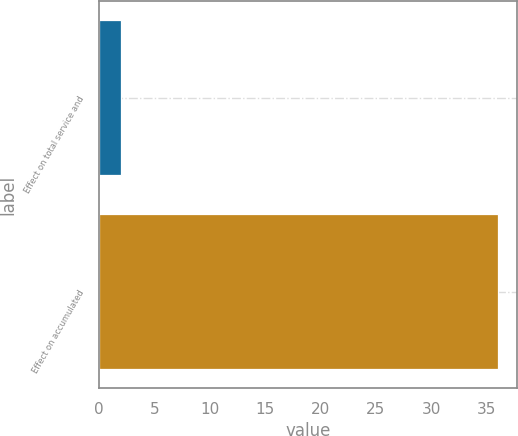<chart> <loc_0><loc_0><loc_500><loc_500><bar_chart><fcel>Effect on total service and<fcel>Effect on accumulated<nl><fcel>2<fcel>36<nl></chart> 